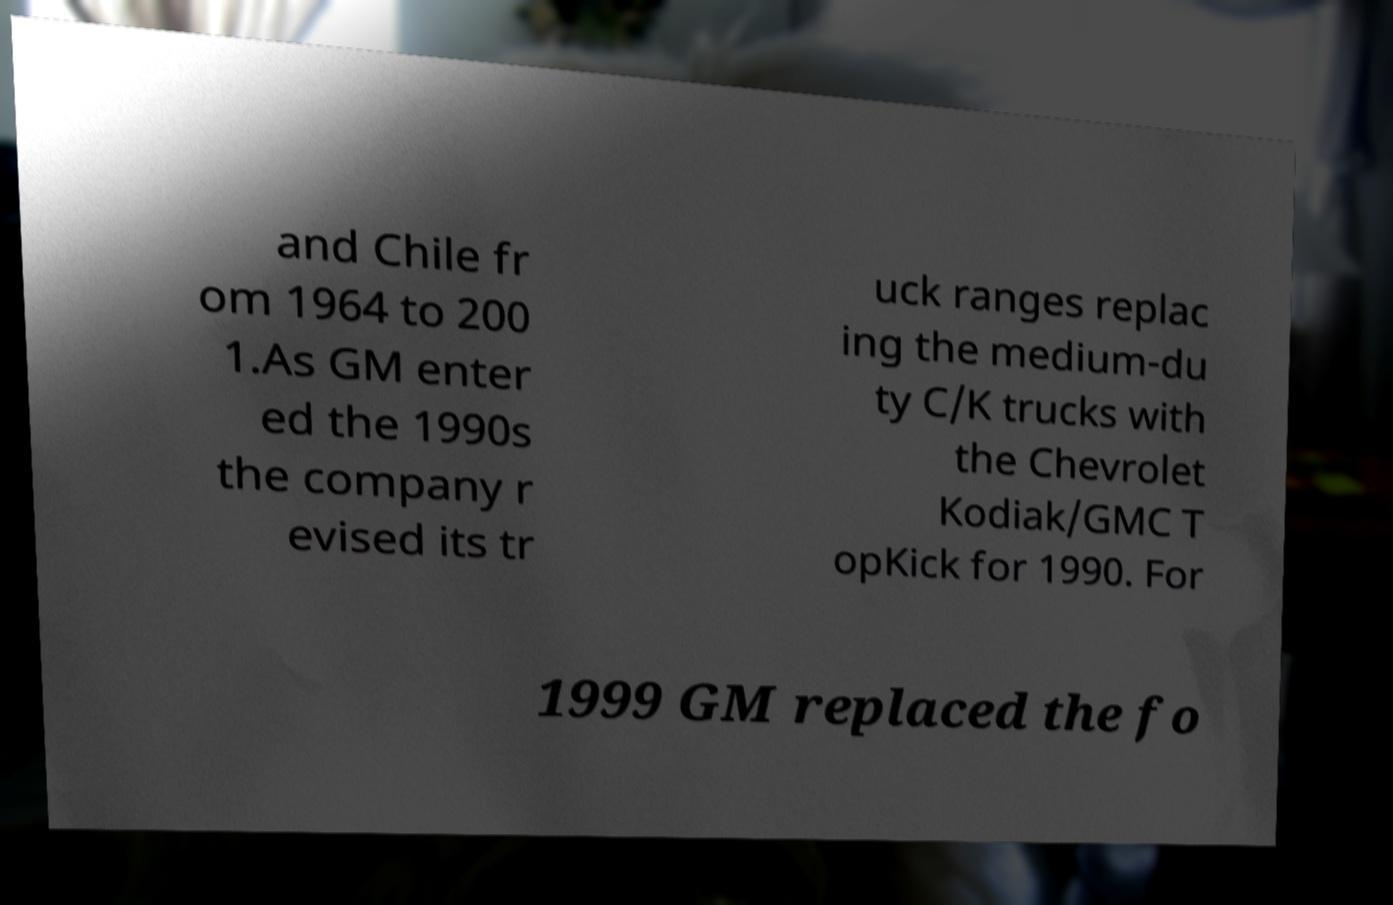Can you accurately transcribe the text from the provided image for me? and Chile fr om 1964 to 200 1.As GM enter ed the 1990s the company r evised its tr uck ranges replac ing the medium-du ty C/K trucks with the Chevrolet Kodiak/GMC T opKick for 1990. For 1999 GM replaced the fo 